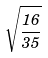Convert formula to latex. <formula><loc_0><loc_0><loc_500><loc_500>\sqrt { \frac { 1 6 } { 3 5 } }</formula> 